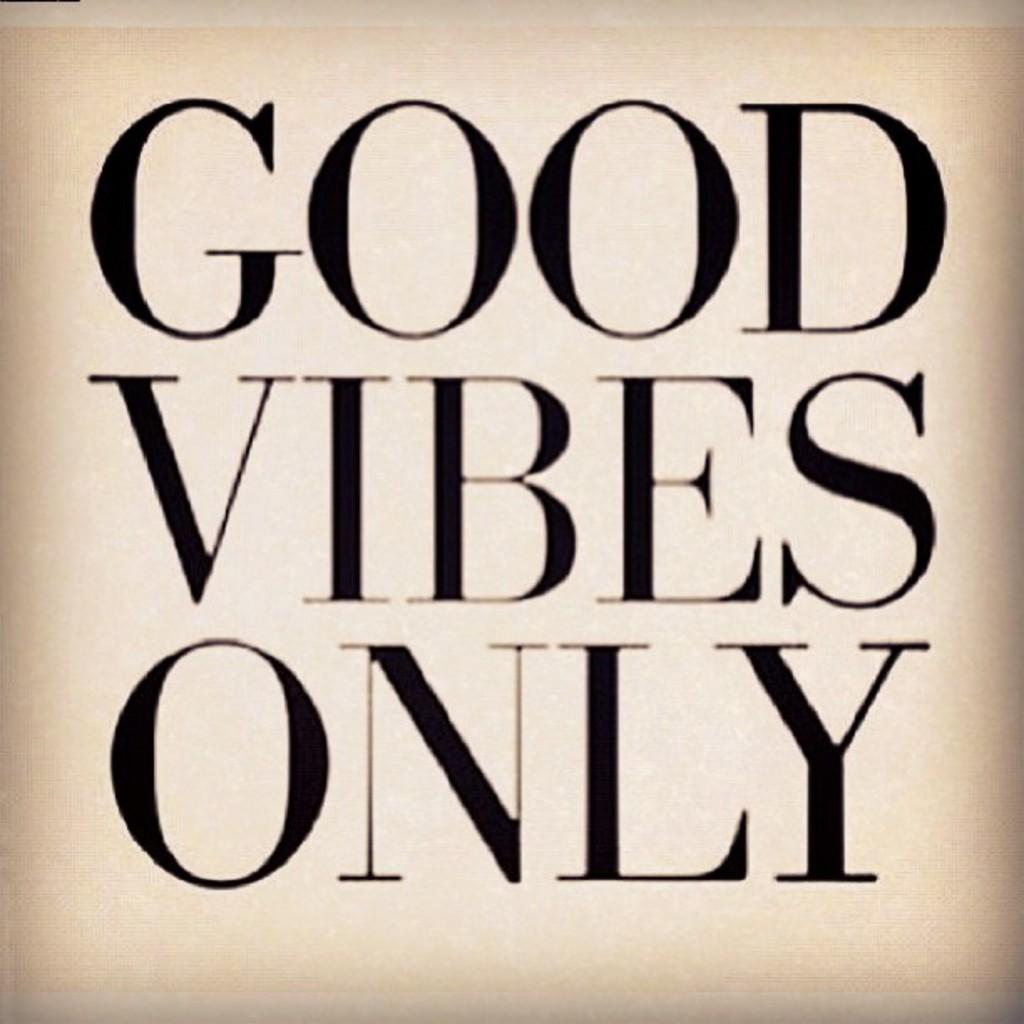Provide a one-sentence caption for the provided image. Words that say Good Vibes Only in black with a tan background. 